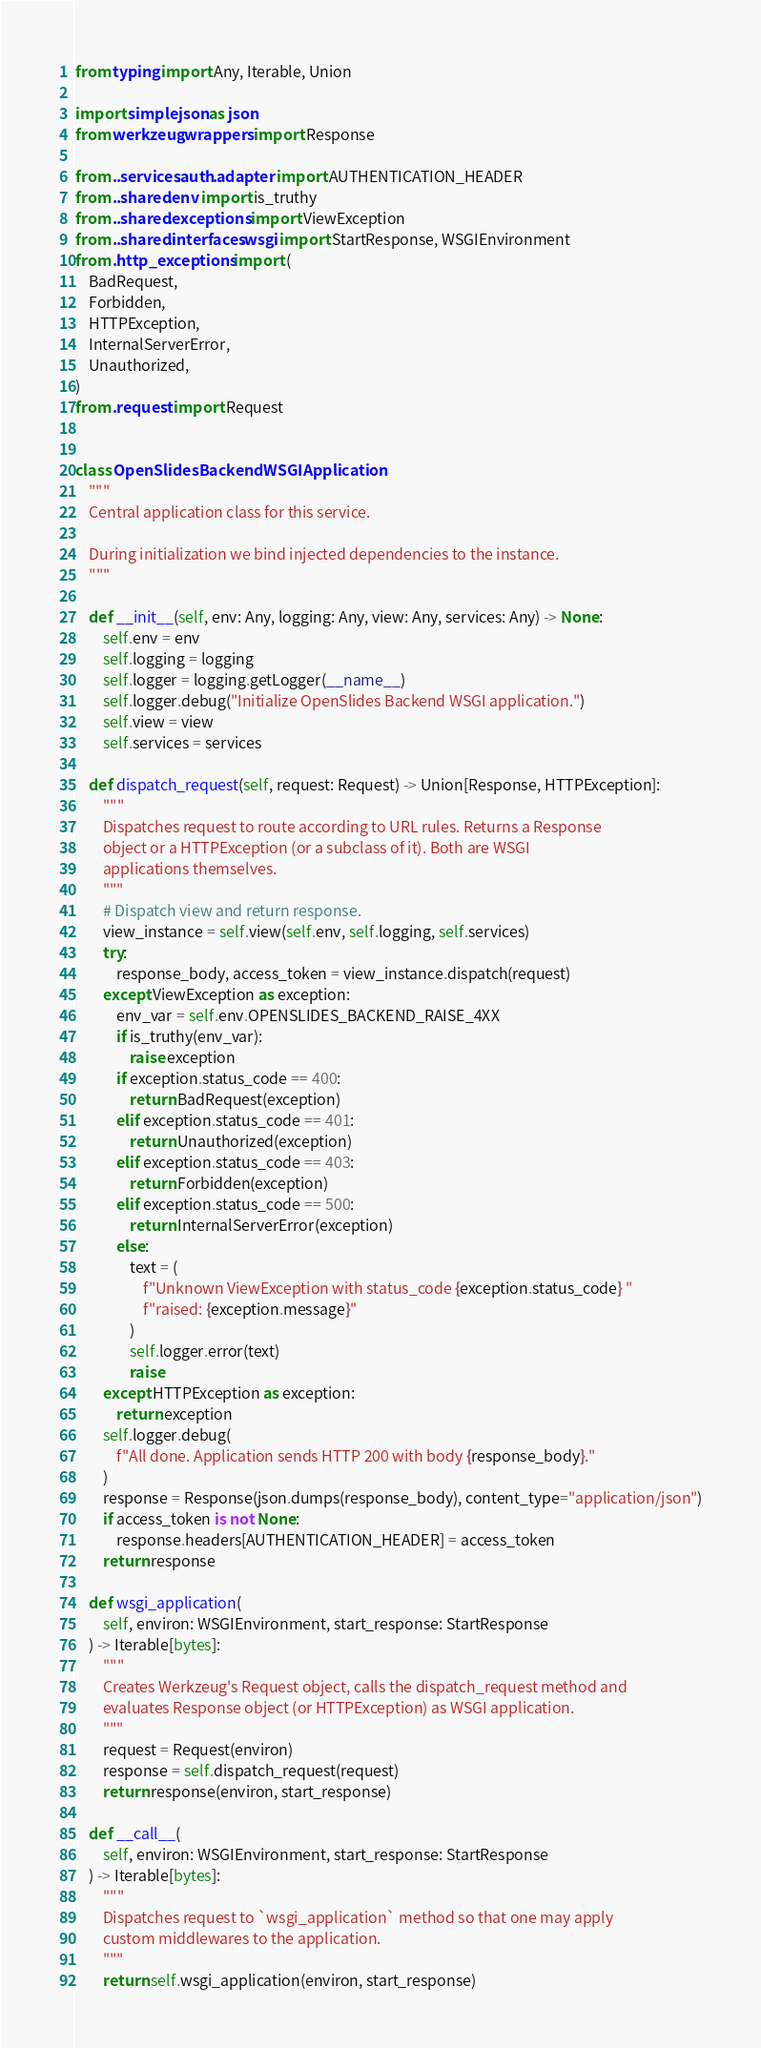<code> <loc_0><loc_0><loc_500><loc_500><_Python_>from typing import Any, Iterable, Union

import simplejson as json
from werkzeug.wrappers import Response

from ..services.auth.adapter import AUTHENTICATION_HEADER
from ..shared.env import is_truthy
from ..shared.exceptions import ViewException
from ..shared.interfaces.wsgi import StartResponse, WSGIEnvironment
from .http_exceptions import (
    BadRequest,
    Forbidden,
    HTTPException,
    InternalServerError,
    Unauthorized,
)
from .request import Request


class OpenSlidesBackendWSGIApplication:
    """
    Central application class for this service.

    During initialization we bind injected dependencies to the instance.
    """

    def __init__(self, env: Any, logging: Any, view: Any, services: Any) -> None:
        self.env = env
        self.logging = logging
        self.logger = logging.getLogger(__name__)
        self.logger.debug("Initialize OpenSlides Backend WSGI application.")
        self.view = view
        self.services = services

    def dispatch_request(self, request: Request) -> Union[Response, HTTPException]:
        """
        Dispatches request to route according to URL rules. Returns a Response
        object or a HTTPException (or a subclass of it). Both are WSGI
        applications themselves.
        """
        # Dispatch view and return response.
        view_instance = self.view(self.env, self.logging, self.services)
        try:
            response_body, access_token = view_instance.dispatch(request)
        except ViewException as exception:
            env_var = self.env.OPENSLIDES_BACKEND_RAISE_4XX
            if is_truthy(env_var):
                raise exception
            if exception.status_code == 400:
                return BadRequest(exception)
            elif exception.status_code == 401:
                return Unauthorized(exception)
            elif exception.status_code == 403:
                return Forbidden(exception)
            elif exception.status_code == 500:
                return InternalServerError(exception)
            else:
                text = (
                    f"Unknown ViewException with status_code {exception.status_code} "
                    f"raised: {exception.message}"
                )
                self.logger.error(text)
                raise
        except HTTPException as exception:
            return exception
        self.logger.debug(
            f"All done. Application sends HTTP 200 with body {response_body}."
        )
        response = Response(json.dumps(response_body), content_type="application/json")
        if access_token is not None:
            response.headers[AUTHENTICATION_HEADER] = access_token
        return response

    def wsgi_application(
        self, environ: WSGIEnvironment, start_response: StartResponse
    ) -> Iterable[bytes]:
        """
        Creates Werkzeug's Request object, calls the dispatch_request method and
        evaluates Response object (or HTTPException) as WSGI application.
        """
        request = Request(environ)
        response = self.dispatch_request(request)
        return response(environ, start_response)

    def __call__(
        self, environ: WSGIEnvironment, start_response: StartResponse
    ) -> Iterable[bytes]:
        """
        Dispatches request to `wsgi_application` method so that one may apply
        custom middlewares to the application.
        """
        return self.wsgi_application(environ, start_response)
</code> 